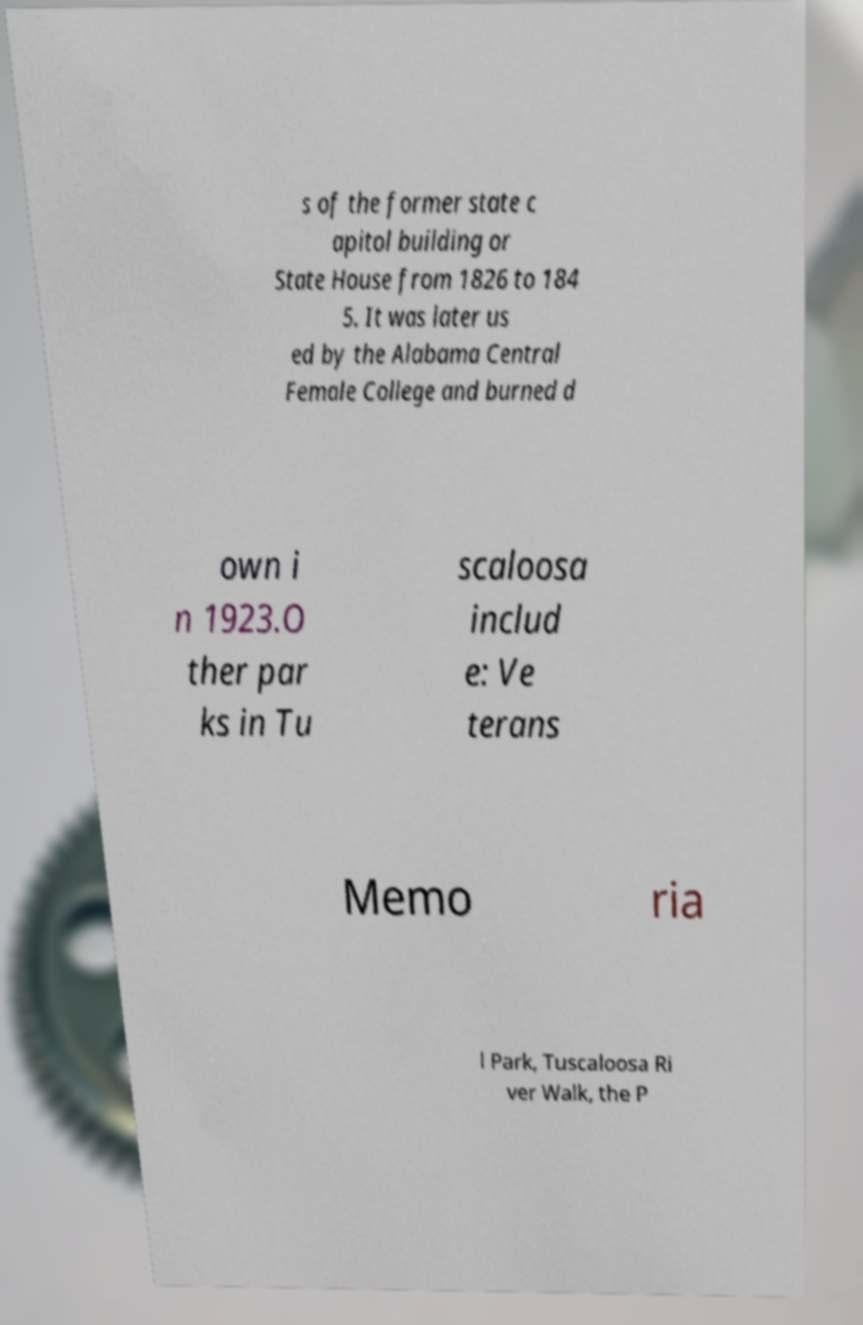Can you accurately transcribe the text from the provided image for me? s of the former state c apitol building or State House from 1826 to 184 5. It was later us ed by the Alabama Central Female College and burned d own i n 1923.O ther par ks in Tu scaloosa includ e: Ve terans Memo ria l Park, Tuscaloosa Ri ver Walk, the P 